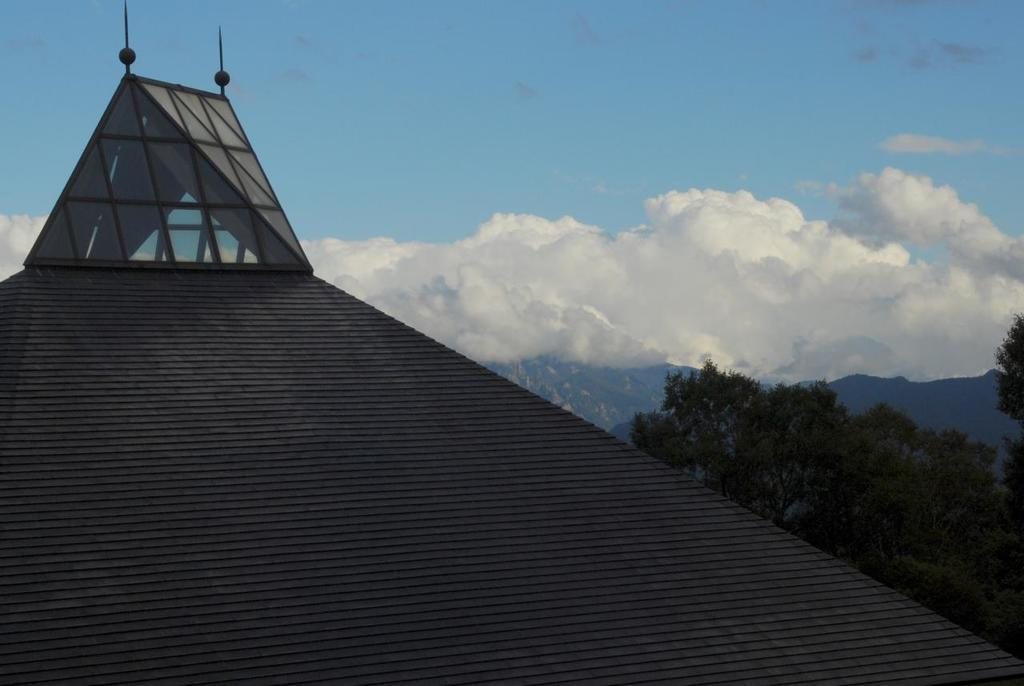What structure is the main focus of the image? There is a dome in the image. What can be seen in the background of the image? There are trees in the background of the image. What is the color of the trees? The trees are green. What is visible above the trees in the image? The sky is visible in the image. How would you describe the color of the sky? The sky has both white and blue colors. Can you see any police officers near the dome in the image? There is no mention of police officers in the image, so we cannot determine if they are present or not. 